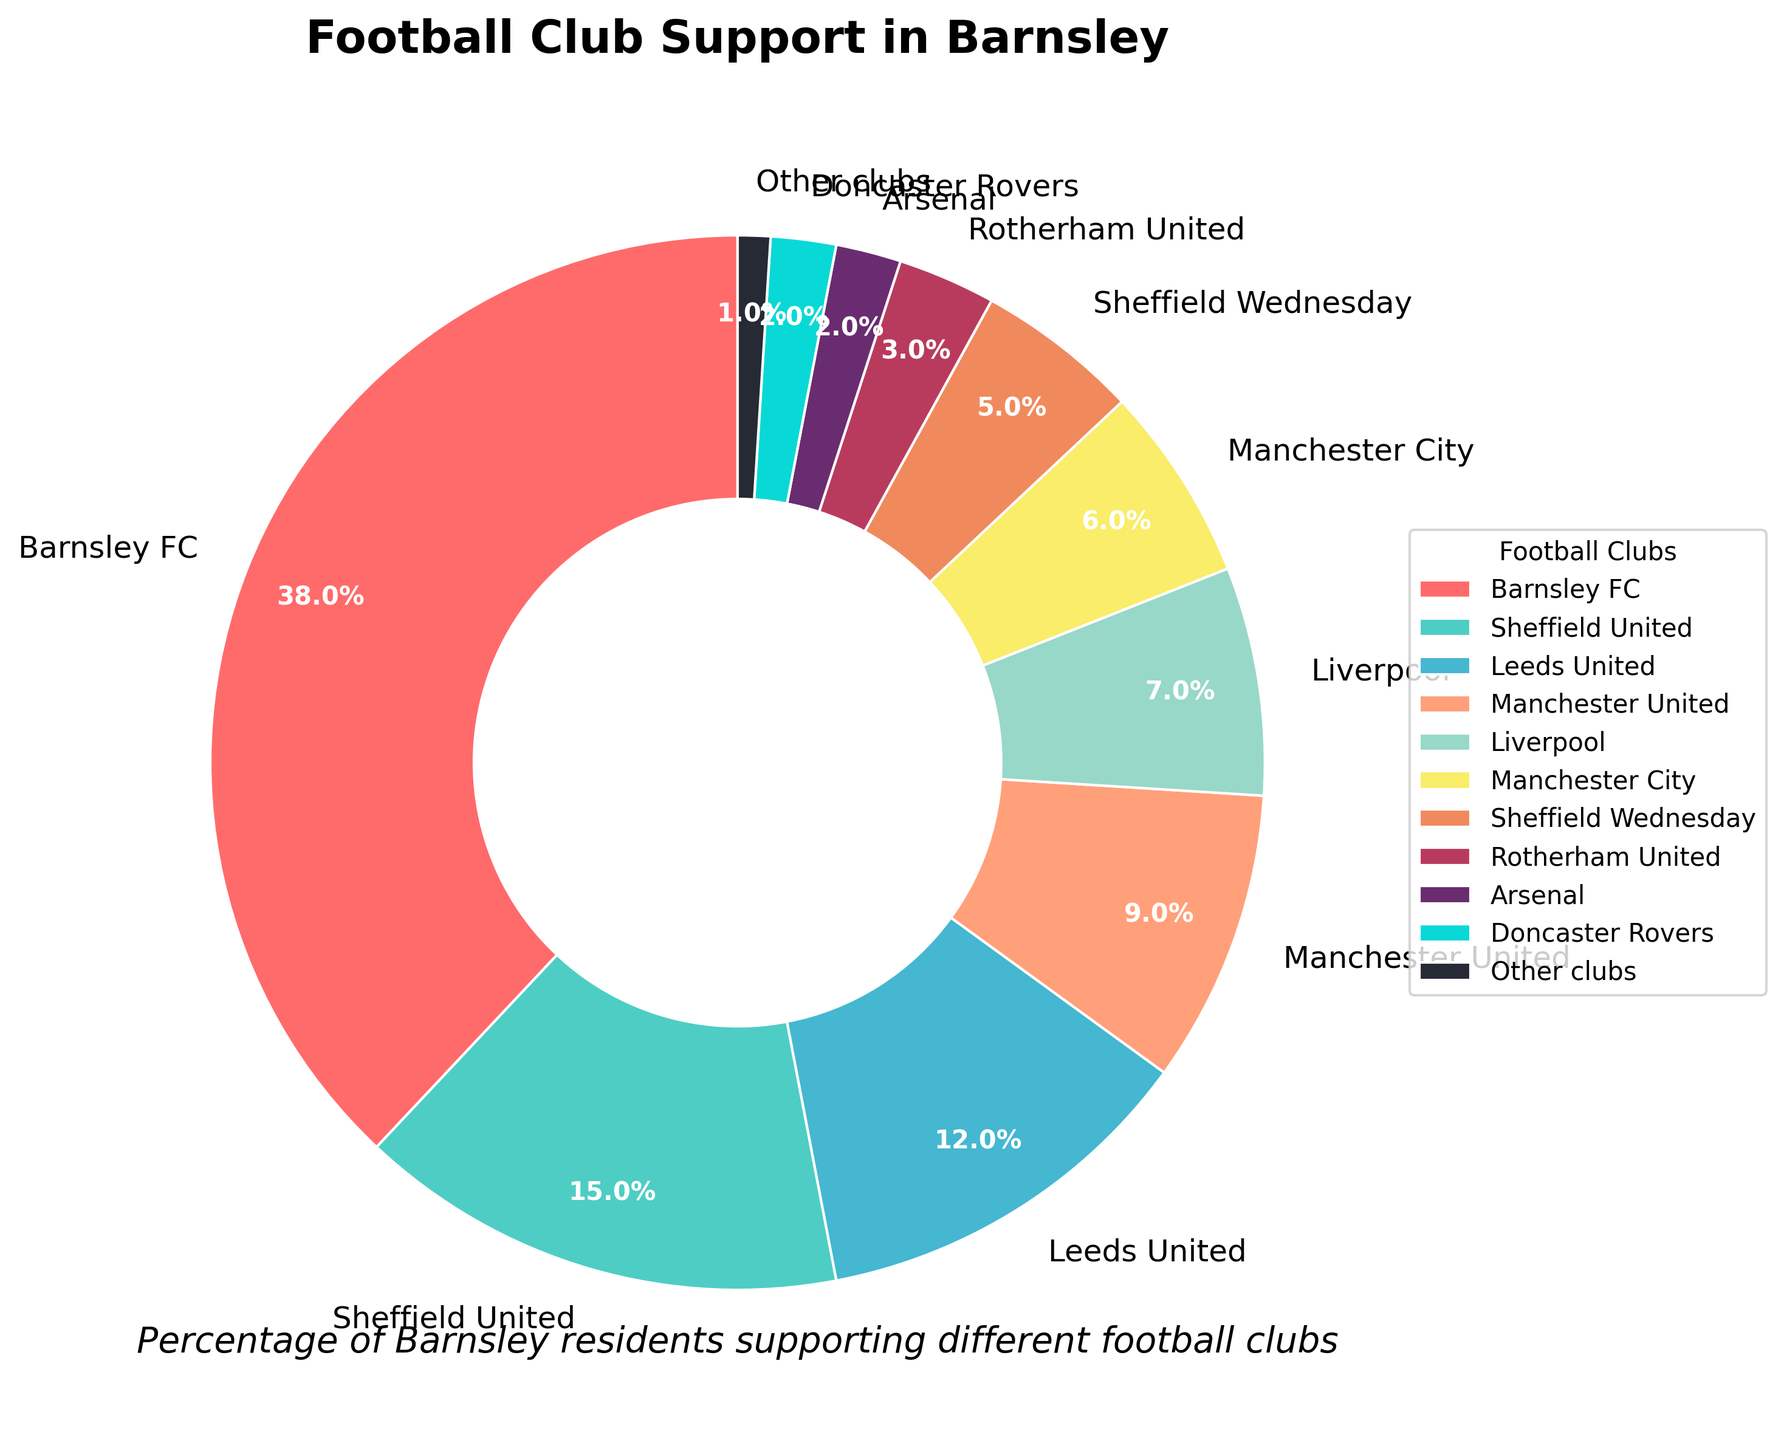What's the most popular football club among Barnsley residents? Barnsley FC has the highest percentage in the pie chart, indicating it is the most popular club among residents.
Answer: Barnsley FC Which two clubs have the smallest support among Barnsley residents? Arsenal and Doncaster Rovers both have a 2% share, the lowest percentages in the pie chart, aside from "Other clubs" which has 1%.
Answer: Arsenal and Doncaster Rovers How much more support does Barnsley FC have compared to Sheffield United? Barnsley FC has a support percentage of 38%, while Sheffield United has 15%. The difference is 38% - 15% = 23%.
Answer: 23% If you combine the support percentages for Manchester United and Manchester City, do they surpass that of Leeds United? Manchester United has 9% and Manchester City has 6%. Together, they have 9% + 6% = 15%, which is equal to the 15% support for Sheffield United. Therefore, they do surpass Leeds United’s 12%.
Answer: Yes What is the combined support percentage of the two Sheffield clubs? Sheffield United has 15% support and Sheffield Wednesday has 5% support. Combined, it is 15% + 5% = 20%.
Answer: 20% Which color corresponds to Liverpool on the pie chart? Liverpool is represented by the color light yellow, as noticed in the visual differences among pie slices.
Answer: Light yellow How much more support does the most popular club have compared to the least popular club? Barnsley FC has 38% support and "Other clubs" have 1%. The difference is 38% - 1% = 37%.
Answer: 37% List the clubs that have more than 10% support among Barnsley residents. The clubs with more than 10% support are Barnsley FC (38%), Sheffield United (15%), and Leeds United (12%).
Answer: Barnsley FC, Sheffield United, Leeds United What's the combined percentage of support for the clubs that originate from Manchester? Manchester United has 9% and Manchester City has 6%. Their combined support is 9% + 6% = 15%.
Answer: 15% Rank the clubs by their support percentages in descending order. Barnsley FC (38%), Sheffield United (15%), Leeds United (12%), Manchester United (9%), Liverpool (7%), Manchester City (6%), Sheffield Wednesday (5%), Rotherham United (3%), Arsenal (2%), Doncaster Rovers (2%), Other clubs (1%).
Answer: Barnsley FC, Sheffield United, Leeds United, Manchester United, Liverpool, Manchester City, Sheffield Wednesday, Rotherham United, Arsenal, Doncaster Rovers, Other clubs 